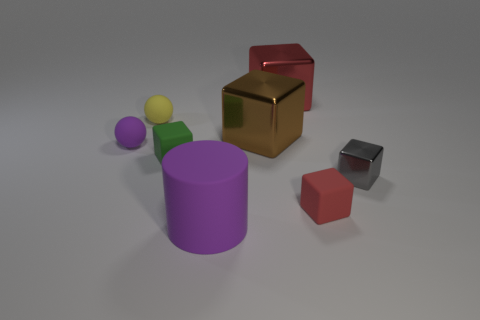Subtract 1 blocks. How many blocks are left? 4 Subtract all red metal blocks. How many blocks are left? 4 Subtract all brown cubes. How many cubes are left? 4 Subtract all gray blocks. Subtract all red cylinders. How many blocks are left? 4 Add 1 small rubber things. How many objects exist? 9 Subtract all spheres. How many objects are left? 6 Subtract 0 gray spheres. How many objects are left? 8 Subtract all gray objects. Subtract all blocks. How many objects are left? 2 Add 8 large brown cubes. How many large brown cubes are left? 9 Add 2 small yellow spheres. How many small yellow spheres exist? 3 